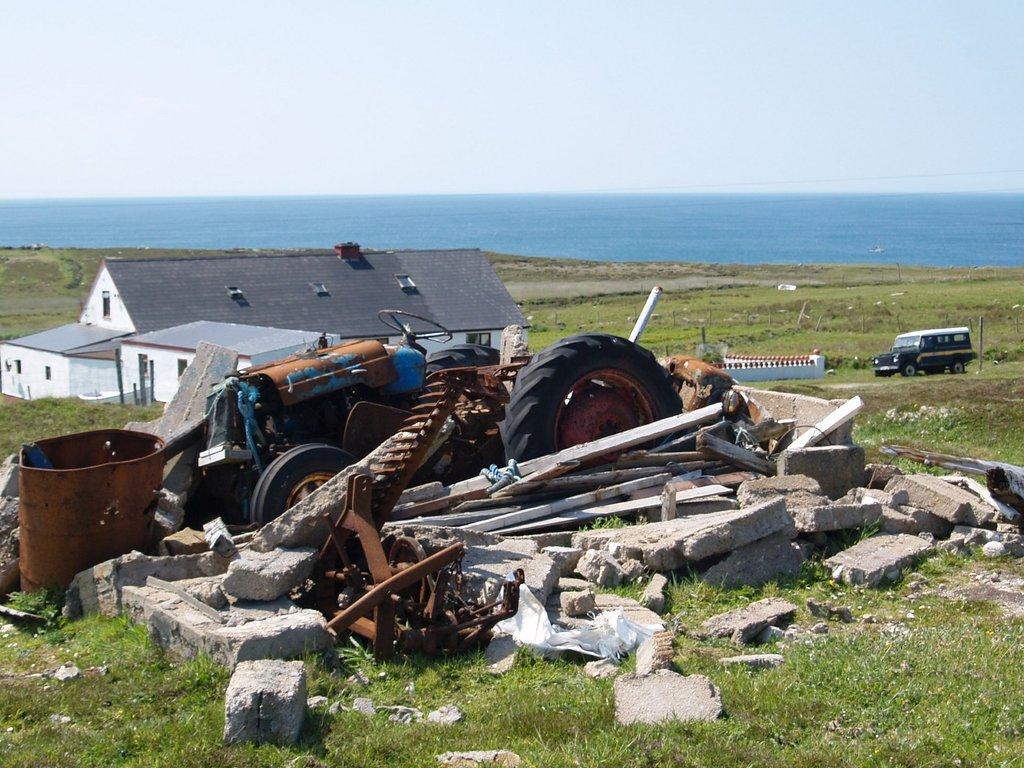Can you describe this image briefly? In the foreground of the picture we can see stones, tractor, grass and iron objects. In the middle of the picture we can see building, car, fields, fencing and road. In the background there is a water body. At the top it is sky. 